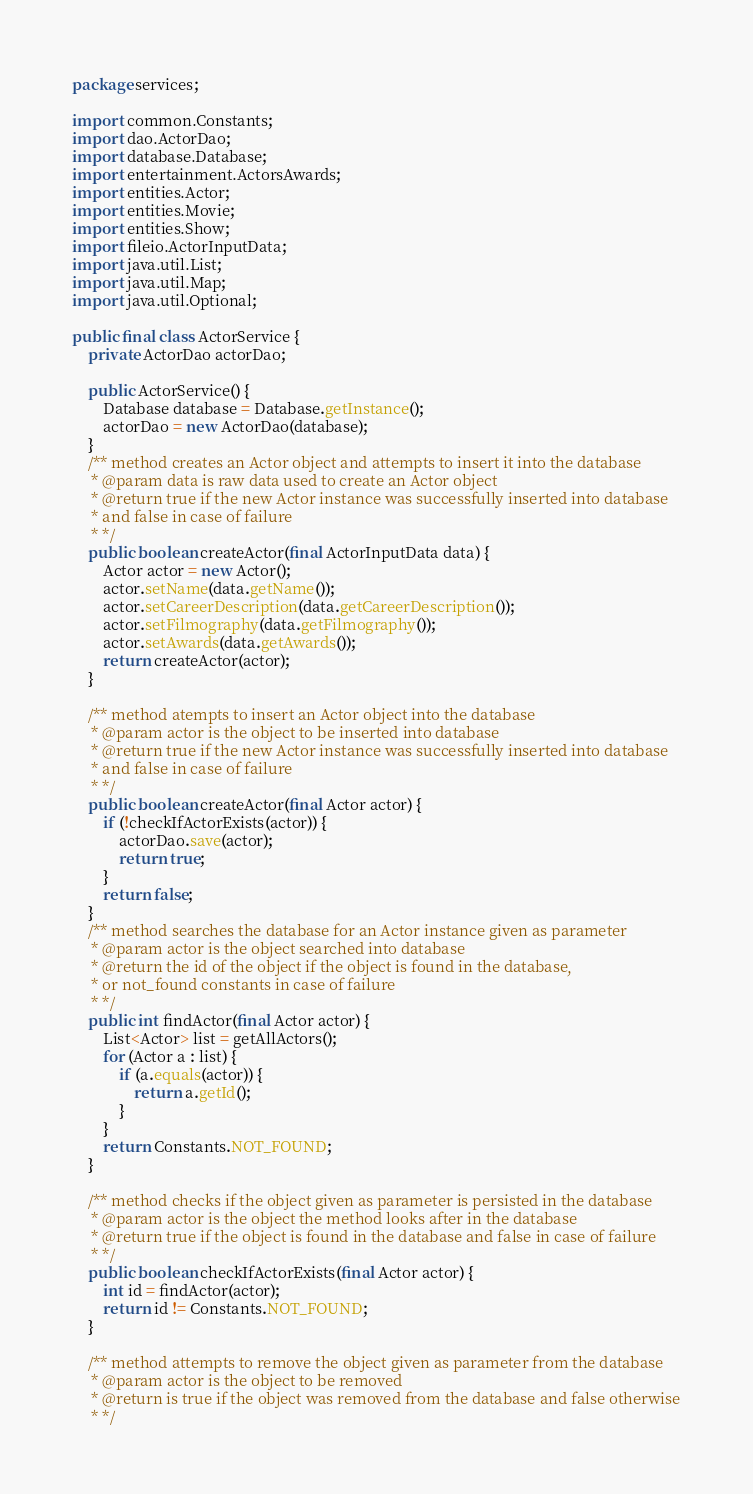Convert code to text. <code><loc_0><loc_0><loc_500><loc_500><_Java_>package services;

import common.Constants;
import dao.ActorDao;
import database.Database;
import entertainment.ActorsAwards;
import entities.Actor;
import entities.Movie;
import entities.Show;
import fileio.ActorInputData;
import java.util.List;
import java.util.Map;
import java.util.Optional;

public final class ActorService {
    private ActorDao actorDao;

    public ActorService() {
        Database database = Database.getInstance();
        actorDao = new ActorDao(database);
    }
    /** method creates an Actor object and attempts to insert it into the database
     * @param data is raw data used to create an Actor object
     * @return true if the new Actor instance was successfully inserted into database
     * and false in case of failure
     * */
    public boolean createActor(final ActorInputData data) {
        Actor actor = new Actor();
        actor.setName(data.getName());
        actor.setCareerDescription(data.getCareerDescription());
        actor.setFilmography(data.getFilmography());
        actor.setAwards(data.getAwards());
        return createActor(actor);
    }

    /** method atempts to insert an Actor object into the database
     * @param actor is the object to be inserted into database
     * @return true if the new Actor instance was successfully inserted into database
     * and false in case of failure
     * */
    public boolean createActor(final Actor actor) {
        if (!checkIfActorExists(actor)) {
            actorDao.save(actor);
            return true;
        }
        return false;
    }
    /** method searches the database for an Actor instance given as parameter
     * @param actor is the object searched into database
     * @return the id of the object if the object is found in the database,
     * or not_found constants in case of failure
     * */
    public int findActor(final Actor actor) {
        List<Actor> list = getAllActors();
        for (Actor a : list) {
            if (a.equals(actor)) {
                return a.getId();
            }
        }
        return Constants.NOT_FOUND;
    }

    /** method checks if the object given as parameter is persisted in the database
     * @param actor is the object the method looks after in the database
     * @return true if the object is found in the database and false in case of failure
     * */
    public boolean checkIfActorExists(final Actor actor) {
        int id = findActor(actor);
        return id != Constants.NOT_FOUND;
    }

    /** method attempts to remove the object given as parameter from the database
     * @param actor is the object to be removed
     * @return is true if the object was removed from the database and false otherwise
     * */</code> 